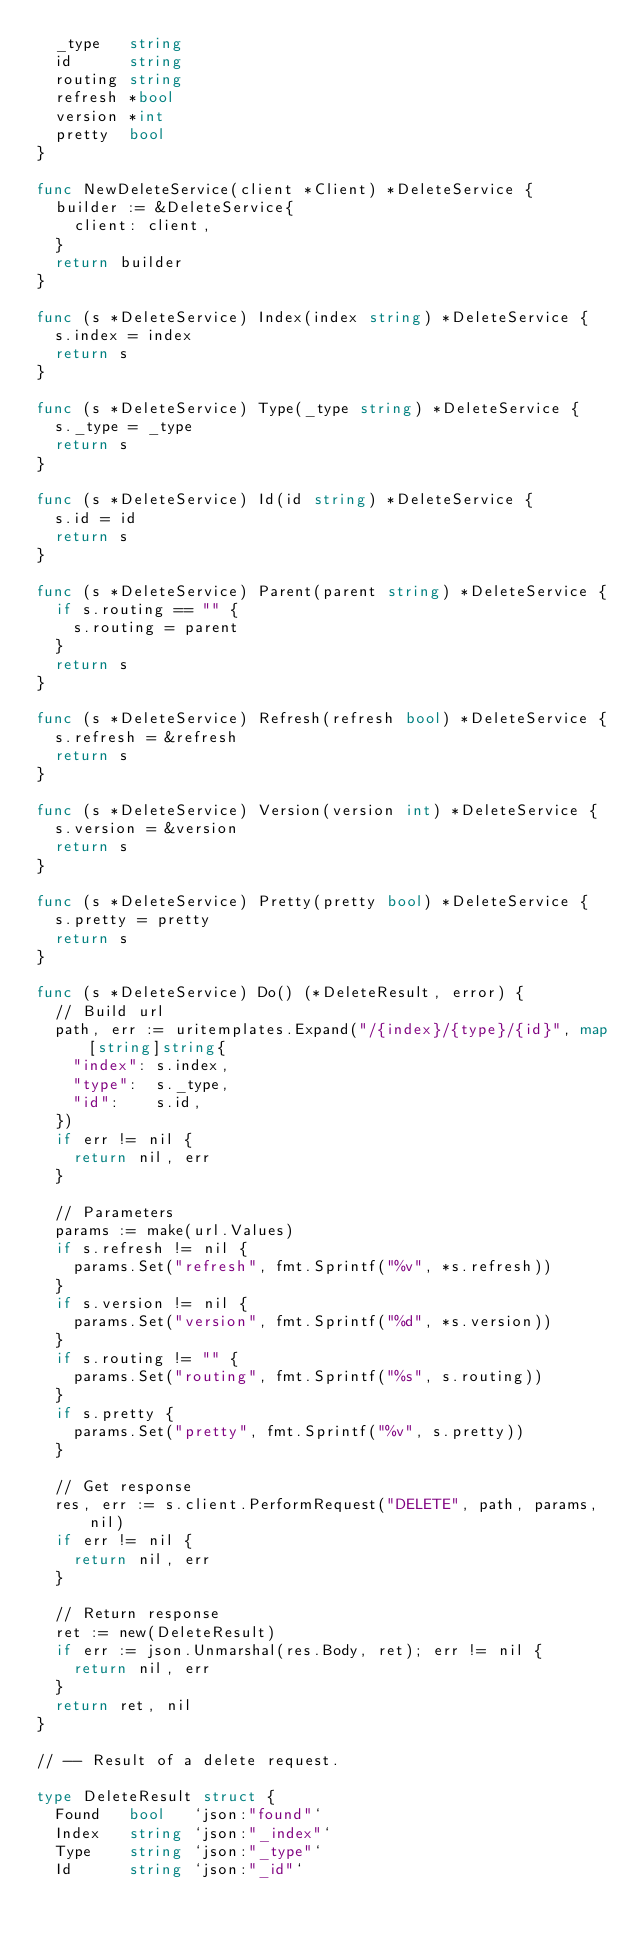Convert code to text. <code><loc_0><loc_0><loc_500><loc_500><_Go_>	_type   string
	id      string
	routing string
	refresh *bool
	version *int
	pretty  bool
}

func NewDeleteService(client *Client) *DeleteService {
	builder := &DeleteService{
		client: client,
	}
	return builder
}

func (s *DeleteService) Index(index string) *DeleteService {
	s.index = index
	return s
}

func (s *DeleteService) Type(_type string) *DeleteService {
	s._type = _type
	return s
}

func (s *DeleteService) Id(id string) *DeleteService {
	s.id = id
	return s
}

func (s *DeleteService) Parent(parent string) *DeleteService {
	if s.routing == "" {
		s.routing = parent
	}
	return s
}

func (s *DeleteService) Refresh(refresh bool) *DeleteService {
	s.refresh = &refresh
	return s
}

func (s *DeleteService) Version(version int) *DeleteService {
	s.version = &version
	return s
}

func (s *DeleteService) Pretty(pretty bool) *DeleteService {
	s.pretty = pretty
	return s
}

func (s *DeleteService) Do() (*DeleteResult, error) {
	// Build url
	path, err := uritemplates.Expand("/{index}/{type}/{id}", map[string]string{
		"index": s.index,
		"type":  s._type,
		"id":    s.id,
	})
	if err != nil {
		return nil, err
	}

	// Parameters
	params := make(url.Values)
	if s.refresh != nil {
		params.Set("refresh", fmt.Sprintf("%v", *s.refresh))
	}
	if s.version != nil {
		params.Set("version", fmt.Sprintf("%d", *s.version))
	}
	if s.routing != "" {
		params.Set("routing", fmt.Sprintf("%s", s.routing))
	}
	if s.pretty {
		params.Set("pretty", fmt.Sprintf("%v", s.pretty))
	}

	// Get response
	res, err := s.client.PerformRequest("DELETE", path, params, nil)
	if err != nil {
		return nil, err
	}

	// Return response
	ret := new(DeleteResult)
	if err := json.Unmarshal(res.Body, ret); err != nil {
		return nil, err
	}
	return ret, nil
}

// -- Result of a delete request.

type DeleteResult struct {
	Found   bool   `json:"found"`
	Index   string `json:"_index"`
	Type    string `json:"_type"`
	Id      string `json:"_id"`</code> 